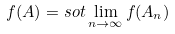<formula> <loc_0><loc_0><loc_500><loc_500>f ( A ) = { s o t } \lim _ { n \to \infty } f ( A _ { n } )</formula> 